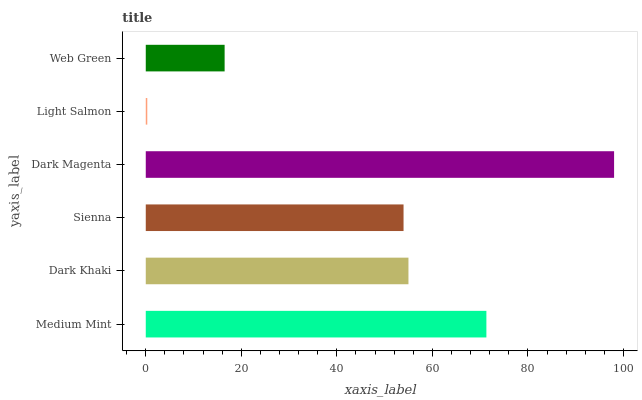Is Light Salmon the minimum?
Answer yes or no. Yes. Is Dark Magenta the maximum?
Answer yes or no. Yes. Is Dark Khaki the minimum?
Answer yes or no. No. Is Dark Khaki the maximum?
Answer yes or no. No. Is Medium Mint greater than Dark Khaki?
Answer yes or no. Yes. Is Dark Khaki less than Medium Mint?
Answer yes or no. Yes. Is Dark Khaki greater than Medium Mint?
Answer yes or no. No. Is Medium Mint less than Dark Khaki?
Answer yes or no. No. Is Dark Khaki the high median?
Answer yes or no. Yes. Is Sienna the low median?
Answer yes or no. Yes. Is Light Salmon the high median?
Answer yes or no. No. Is Light Salmon the low median?
Answer yes or no. No. 